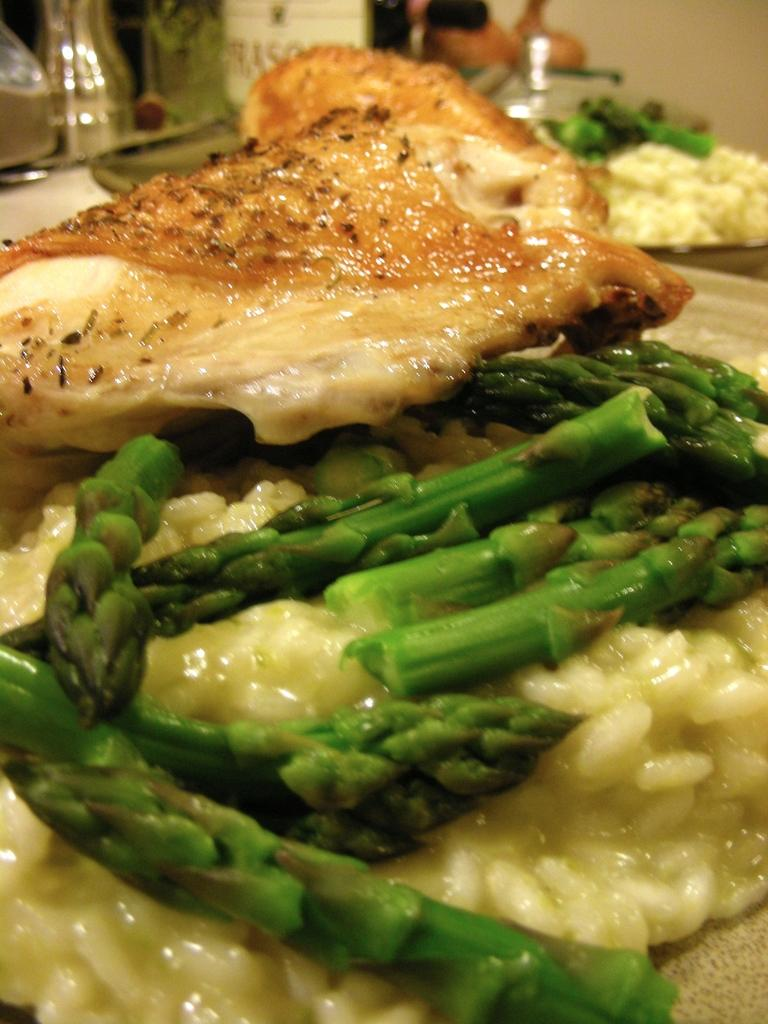What type of objects can be seen in the image? There are food items in the image. What type of desk is visible in the image? There is no desk present in the image; it only contains food items. 